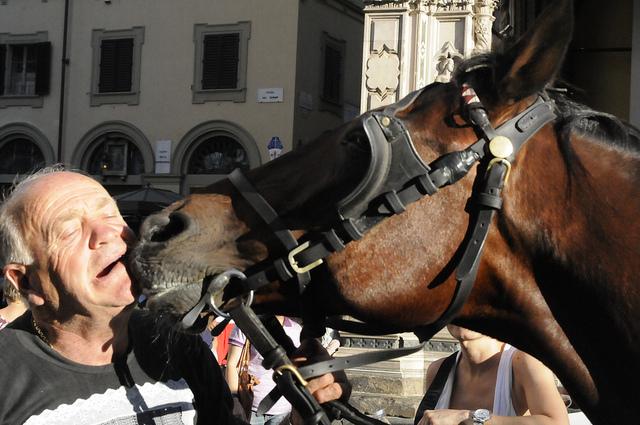What color is the horse's mane?
Write a very short answer. Black. What is the horse doing to the man?
Concise answer only. Kissing. Is the man in a gay relationship?
Be succinct. No. What color is the horse in the picture?
Keep it brief. Brown. What is the position of the person riding the horse?
Give a very brief answer. Standing. 